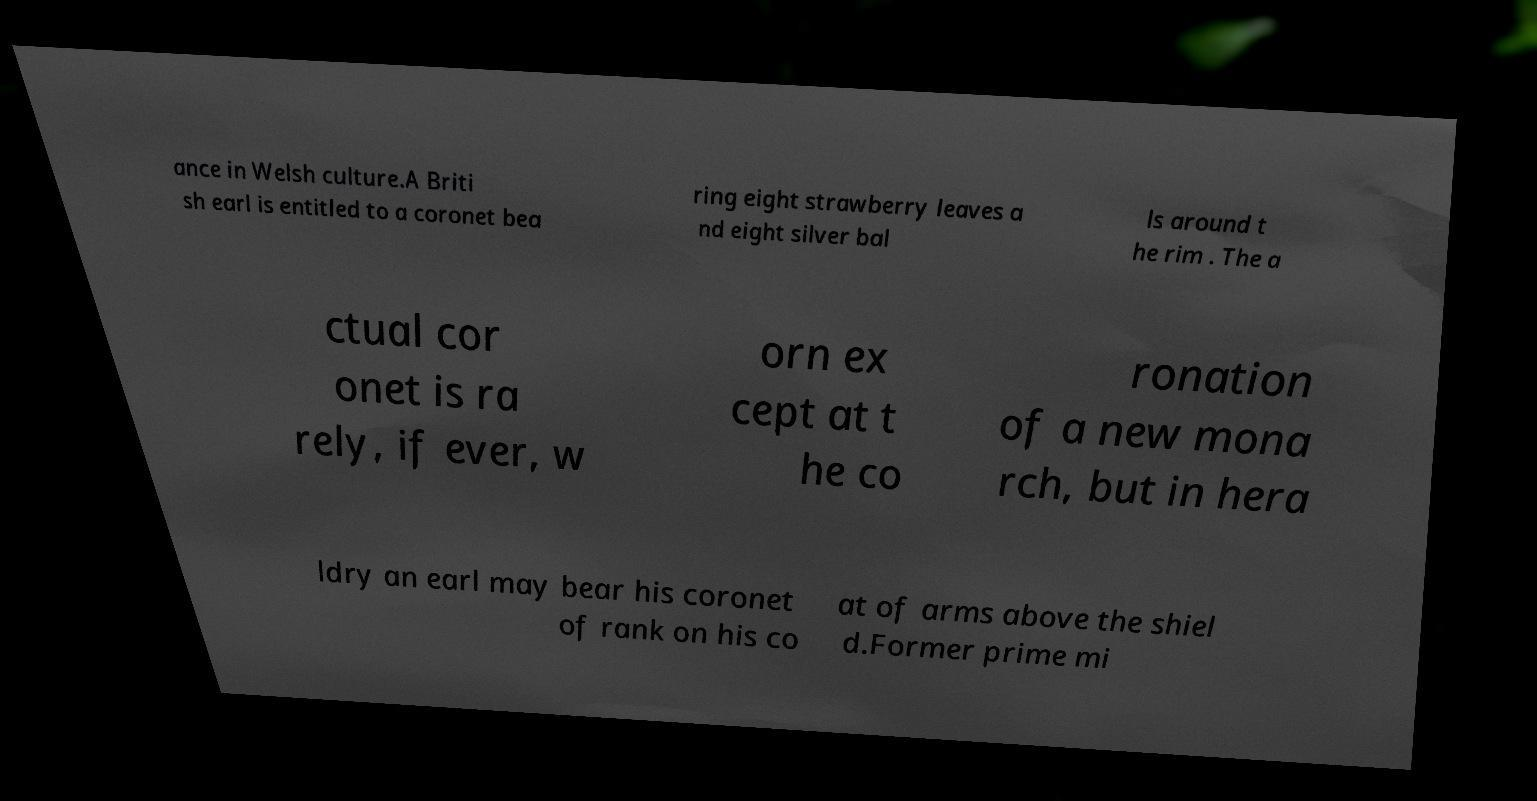I need the written content from this picture converted into text. Can you do that? ance in Welsh culture.A Briti sh earl is entitled to a coronet bea ring eight strawberry leaves a nd eight silver bal ls around t he rim . The a ctual cor onet is ra rely, if ever, w orn ex cept at t he co ronation of a new mona rch, but in hera ldry an earl may bear his coronet of rank on his co at of arms above the shiel d.Former prime mi 